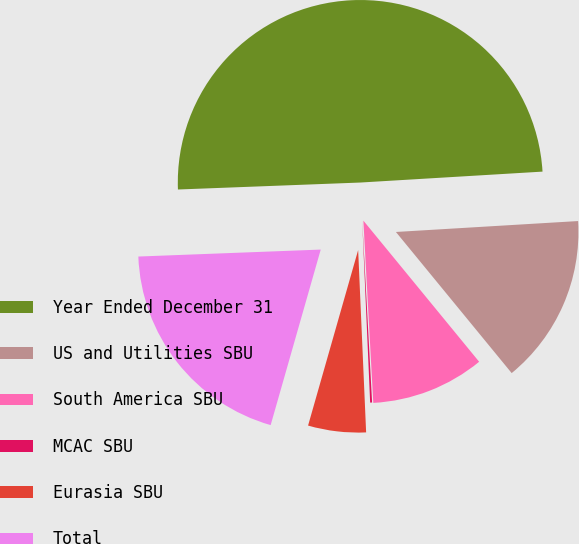<chart> <loc_0><loc_0><loc_500><loc_500><pie_chart><fcel>Year Ended December 31<fcel>US and Utilities SBU<fcel>South America SBU<fcel>MCAC SBU<fcel>Eurasia SBU<fcel>Total<nl><fcel>49.66%<fcel>15.02%<fcel>10.07%<fcel>0.17%<fcel>5.12%<fcel>19.97%<nl></chart> 